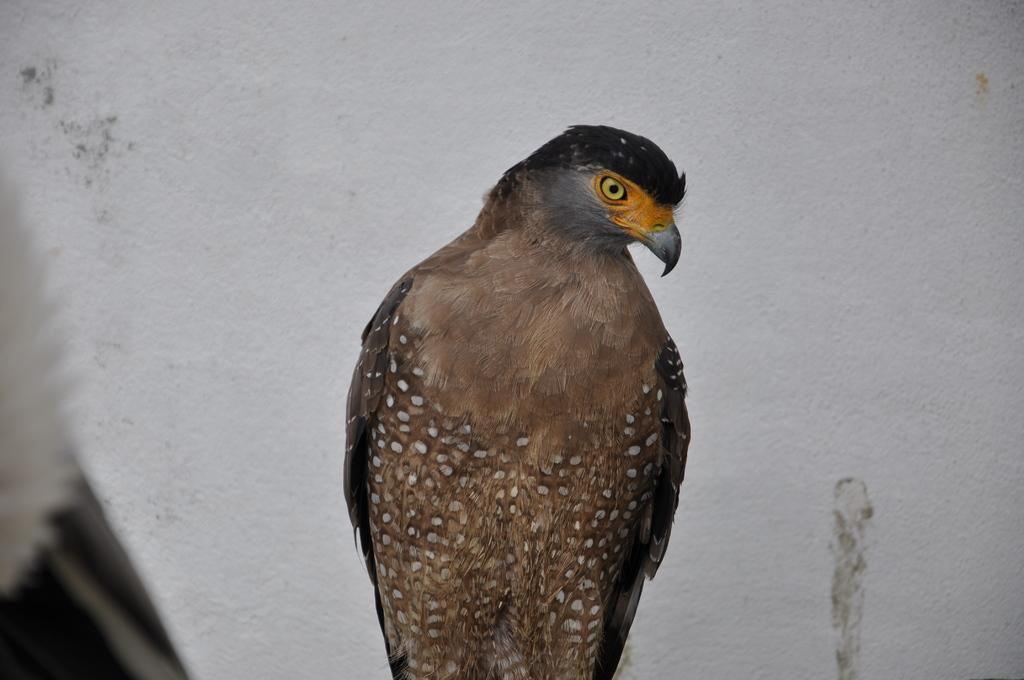What type of bird is in the picture? There is an eagle in the picture. What color are the eagle's feathers? The eagle has brown feathers. What feature is present on the eagle's face? The eagle has a beak. What can be seen in the background of the picture? There is a white wall in the background of the picture. Where is the nearest store to the eagle in the picture? There is no store present in the image; it only features an eagle and a white wall in the background. How many family members are visible in the image? There are no family members present in the image; it only features an eagle and a white wall in the background. 